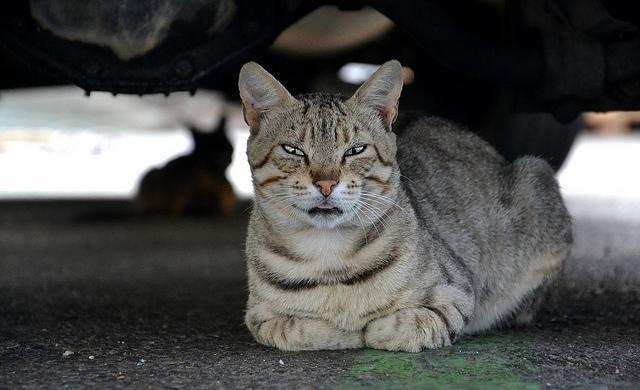How many cats are there?
Give a very brief answer. 2. How many cats can be seen?
Give a very brief answer. 1. How many black umbrella are there?
Give a very brief answer. 0. 